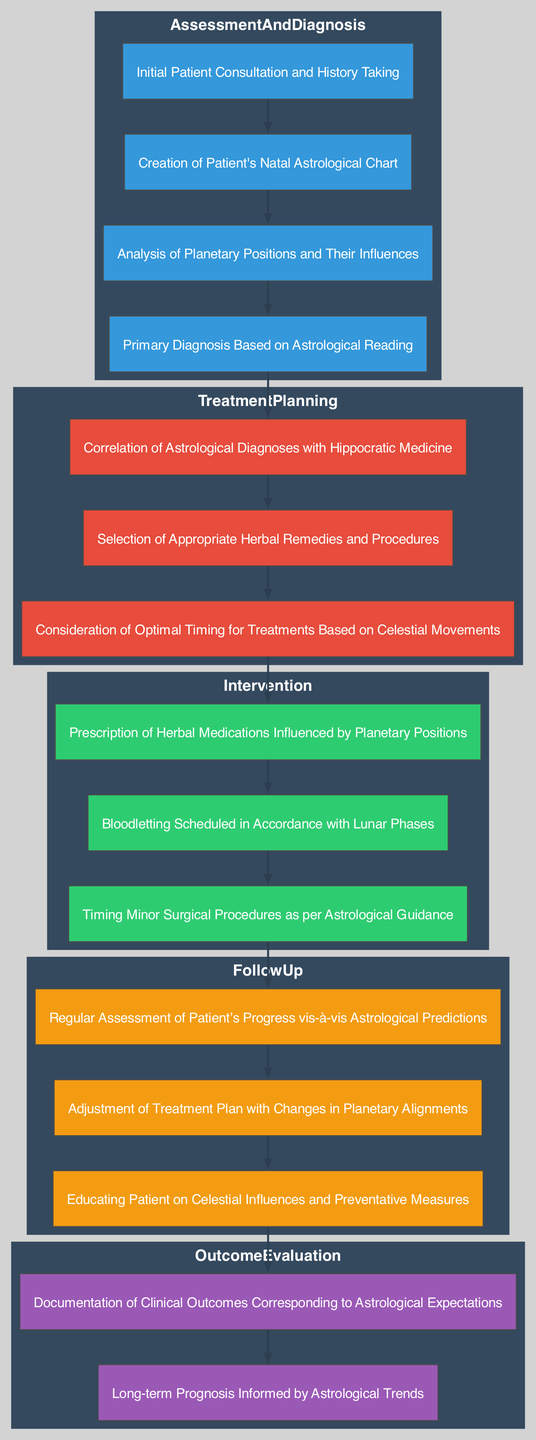What is the first step in the Clinical Pathway? The first step in the Clinical Pathway is the "Initial Patient Consultation and History Taking," which is represented as the first node in the "Assessment and Diagnosis" stage.
Answer: Initial Patient Consultation and History Taking How many main stages are there in the Clinical Pathway? The diagram has four main stages: Assessment and Diagnosis, Treatment Planning, Intervention, and Follow Up, which can be counted by identifying the clusters.
Answer: 4 What determines the timing of minor surgical procedures? The timing of minor surgical procedures is determined by "Astrological Guidance," which can be found within the "Intervention" stage, specifically noted as a connection to celestial influences.
Answer: Astrological Guidance What is the relationship between "Selection of Treatment" and "Hippocratic Correlation"? The "Selection of Treatment" follows the "Hippocratic Correlation," meaning that after diagnosing based on astrological readings, the practitioners then correlate that with Hippocratic medicine before selecting a treatment. This shows a sequential flow from one node to the next.
Answer: Sequential flow What happens if there is a change in planetary alignments? If there is a change in planetary alignments, the "Adjustment of Treatment Plan" will occur, which is a step in the Follow Up stage responsible for recalibrating the patient's treatment.
Answer: Adjustment of Treatment Plan Which stage includes "Prescription of Herbal Medications"? The "Prescription of Herbal Medications" is included in the "Intervention" stage, which entails direct actions taken after treatment planning.
Answer: Intervention What is documented in the last step of Outcome Evaluation? In the last step of Outcome Evaluation, the "Outcome Documentation" is done, noting the clinical outcomes in relation to astrological expectations as the completion of the Clinical Pathway.
Answer: Outcome Documentation Why is "Timing Consideration" crucial in Treatment Planning? "Timing Consideration" is crucial because it ensures that treatments are administered at optimal times influenced by celestial movements, reflecting the interconnectedness of astrology and health practices during the period.
Answer: Optimal timing How does the "Patient Education" node contribute to the pathway? The "Patient Education" node contributes to the pathway by ensuring that patients are informed about celestial influences and preventative measures, promoting a comprehensive approach to health management after intervention.
Answer: Informed patients 